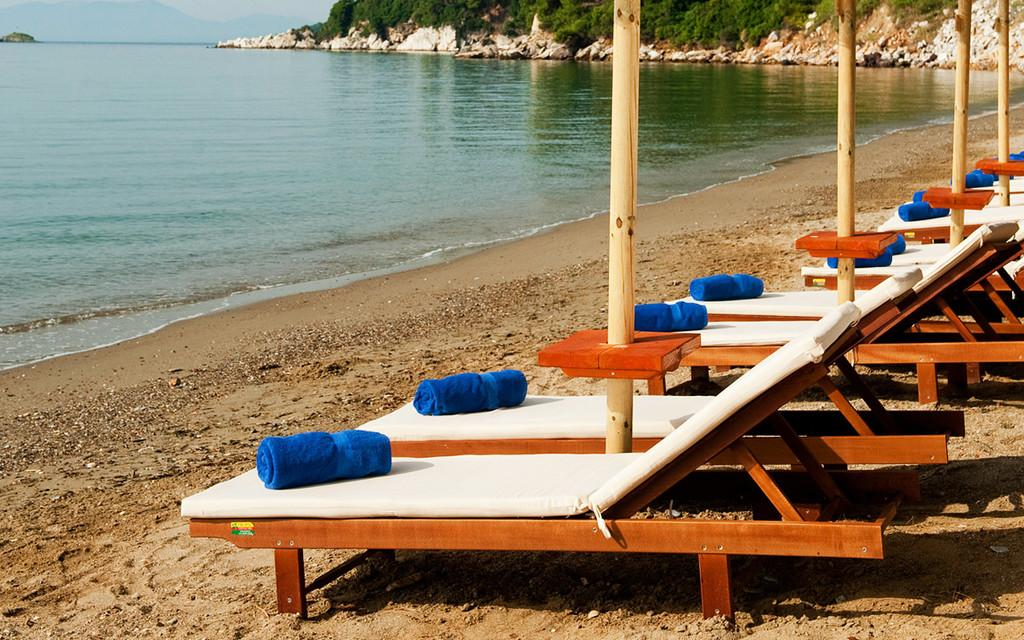What color are the towels on the chairs in the image? The towels on the chairs in the image are blue. What type of material can be seen in the image? Wooden poles are visible in the image. What natural element is present in the image? Water is visible in the image. What can be found on the ground in the image? There are other objects on the ground in the image. What is visible in the background of the image? Trees and rocks are visible in the background of the image. What type of organization is responsible for the animal in the image? There is no animal present in the image, so it is not possible to determine the organization responsible for it. 